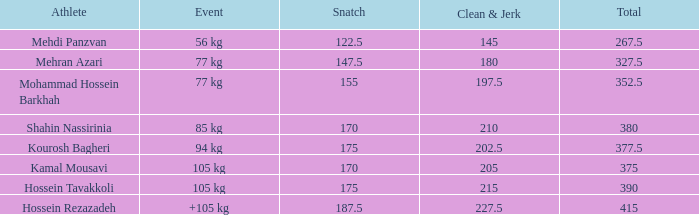What is the overall number that experienced a +105 kg event and a clean & jerk below 22 0.0. 